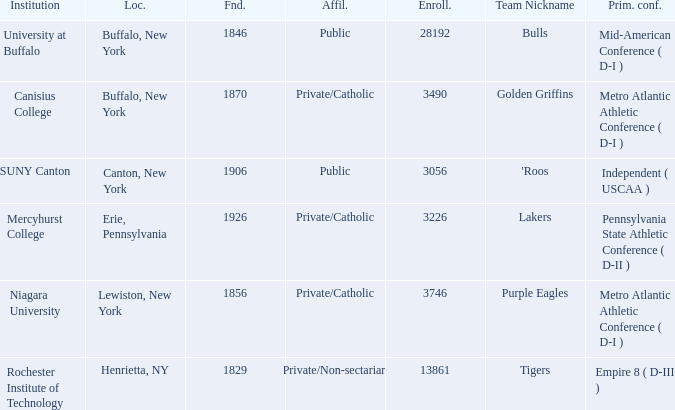What was the enrollment of the school founded in 1846? 28192.0. 